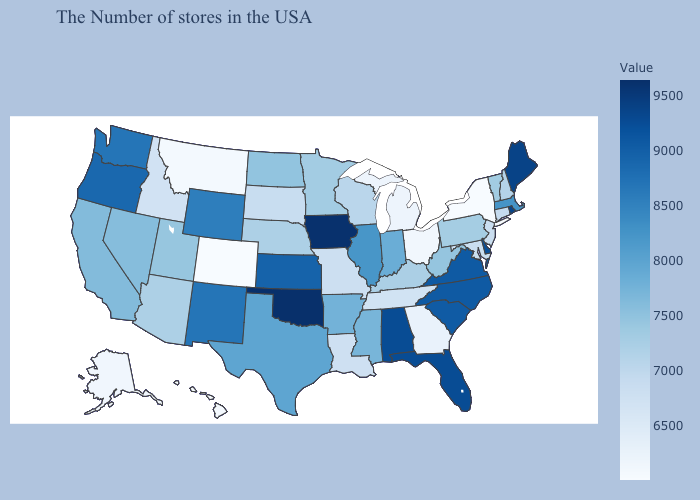Which states hav the highest value in the West?
Quick response, please. Oregon. Does Texas have a lower value than South Dakota?
Write a very short answer. No. Among the states that border Texas , does Oklahoma have the highest value?
Give a very brief answer. Yes. Does Iowa have the highest value in the MidWest?
Write a very short answer. Yes. Which states hav the highest value in the South?
Give a very brief answer. Oklahoma. Which states have the lowest value in the South?
Short answer required. Georgia. Does Rhode Island have the lowest value in the USA?
Keep it brief. No. Which states have the lowest value in the USA?
Write a very short answer. Colorado. Among the states that border Illinois , does Iowa have the highest value?
Give a very brief answer. Yes. 